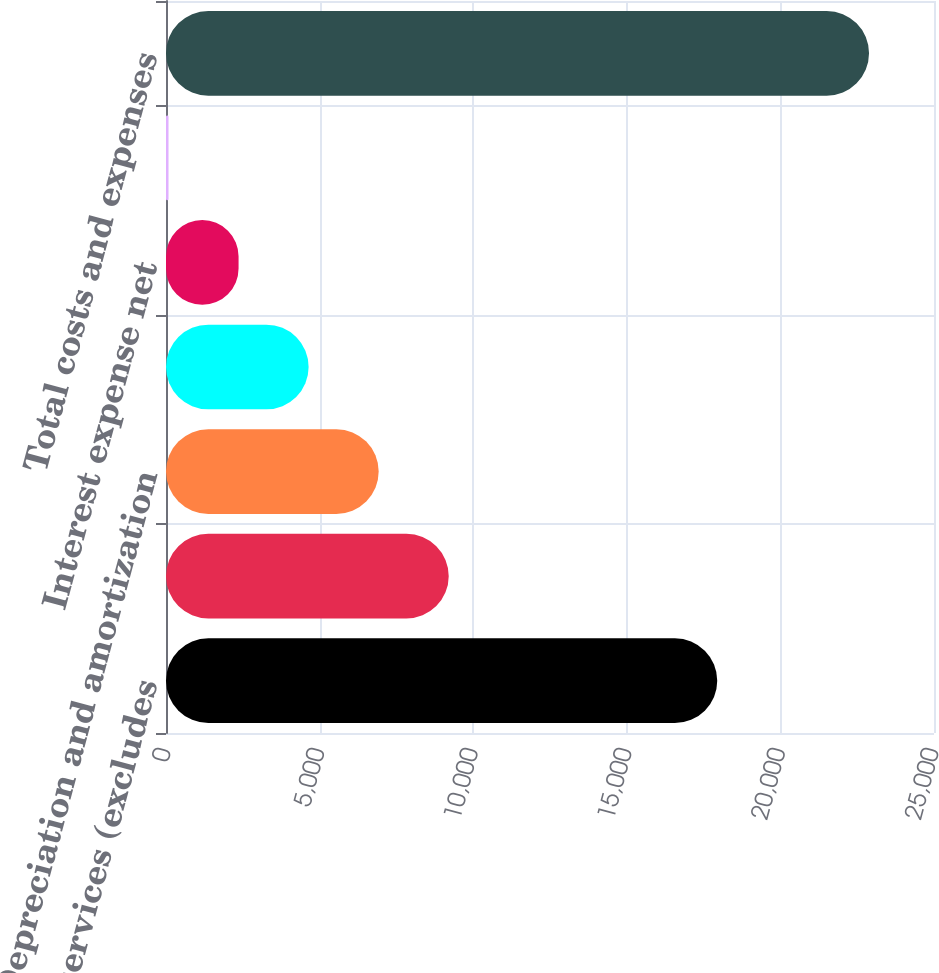<chart> <loc_0><loc_0><loc_500><loc_500><bar_chart><fcel>Costs of services (excludes<fcel>Selling general and<fcel>Depreciation and amortization<fcel>Restructuring costs<fcel>Interest expense net<fcel>Other income net<fcel>Total costs and expenses<nl><fcel>17944<fcel>9203.2<fcel>6922.9<fcel>4642.6<fcel>2362.3<fcel>82<fcel>22885<nl></chart> 